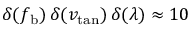<formula> <loc_0><loc_0><loc_500><loc_500>\delta ( f _ { b } ) \, \delta ( v _ { t a n } ) \, \delta ( \lambda ) \approx 1 0</formula> 